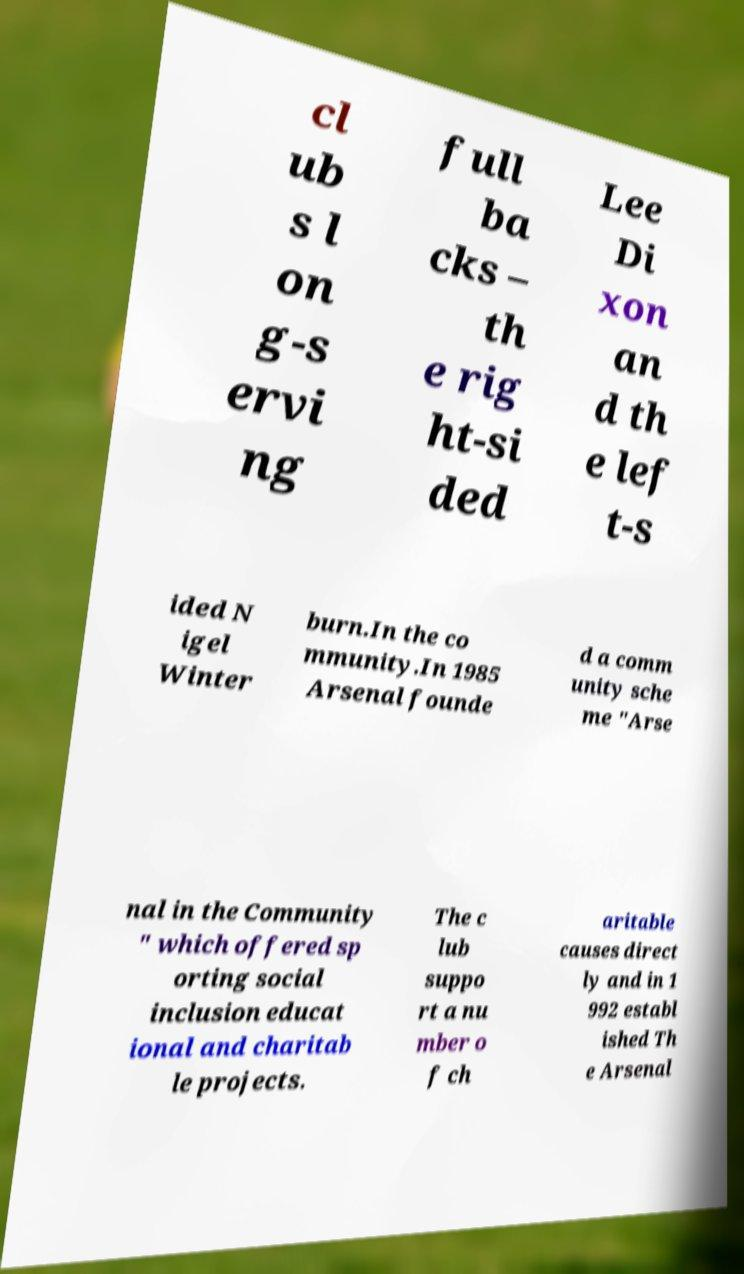Please read and relay the text visible in this image. What does it say? cl ub s l on g-s ervi ng full ba cks – th e rig ht-si ded Lee Di xon an d th e lef t-s ided N igel Winter burn.In the co mmunity.In 1985 Arsenal founde d a comm unity sche me "Arse nal in the Community " which offered sp orting social inclusion educat ional and charitab le projects. The c lub suppo rt a nu mber o f ch aritable causes direct ly and in 1 992 establ ished Th e Arsenal 